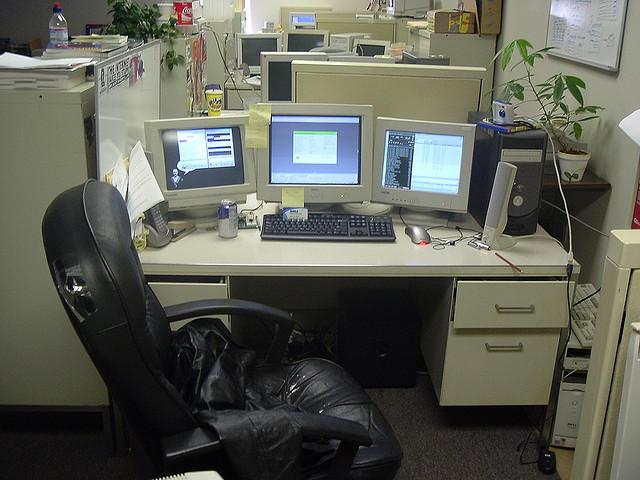Is this a corner office?
Short answer required. No. How much water can the bottle hold that is near the jacket?
Keep it brief. Lot. How many monitors are seen?
Answer briefly. 3. Do you see a plant?
Short answer required. Yes. How many monitors are there?
Give a very brief answer. 3. 